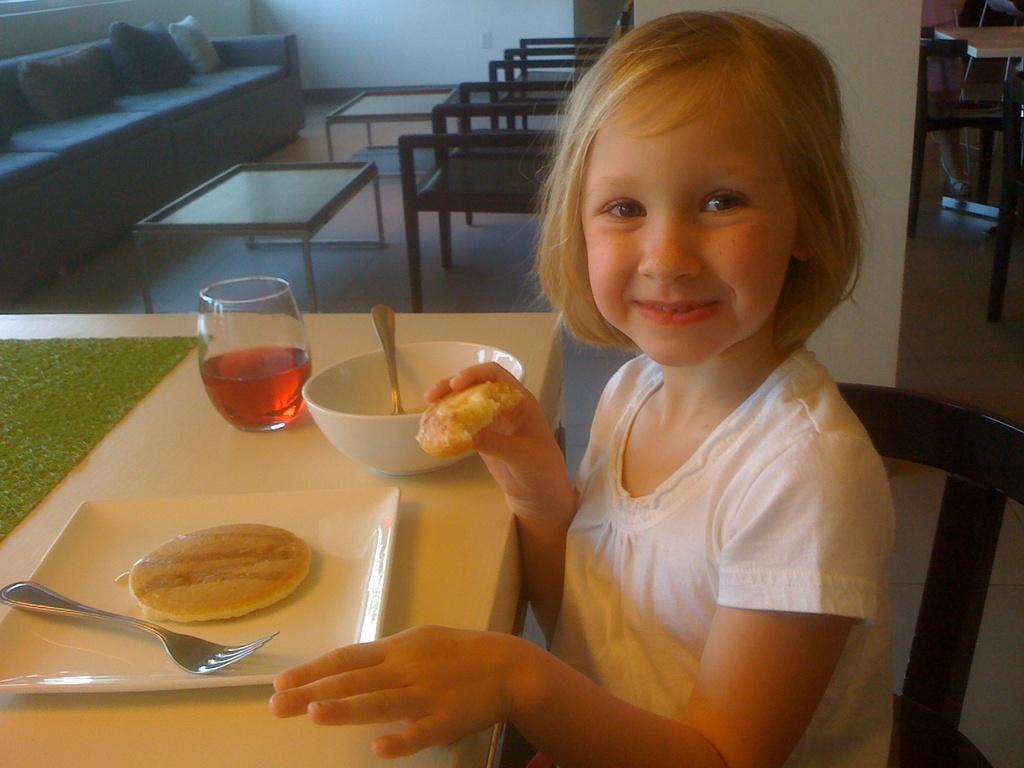Please provide a concise description of this image. In this image, we can see a girl sitting and holding snack in her hand and we can see a bowl, spoon, plate and some food and a glass with drink are placed on the table. In the background, we can see sofa with cushions and tables and chairs and we can see a wall. 